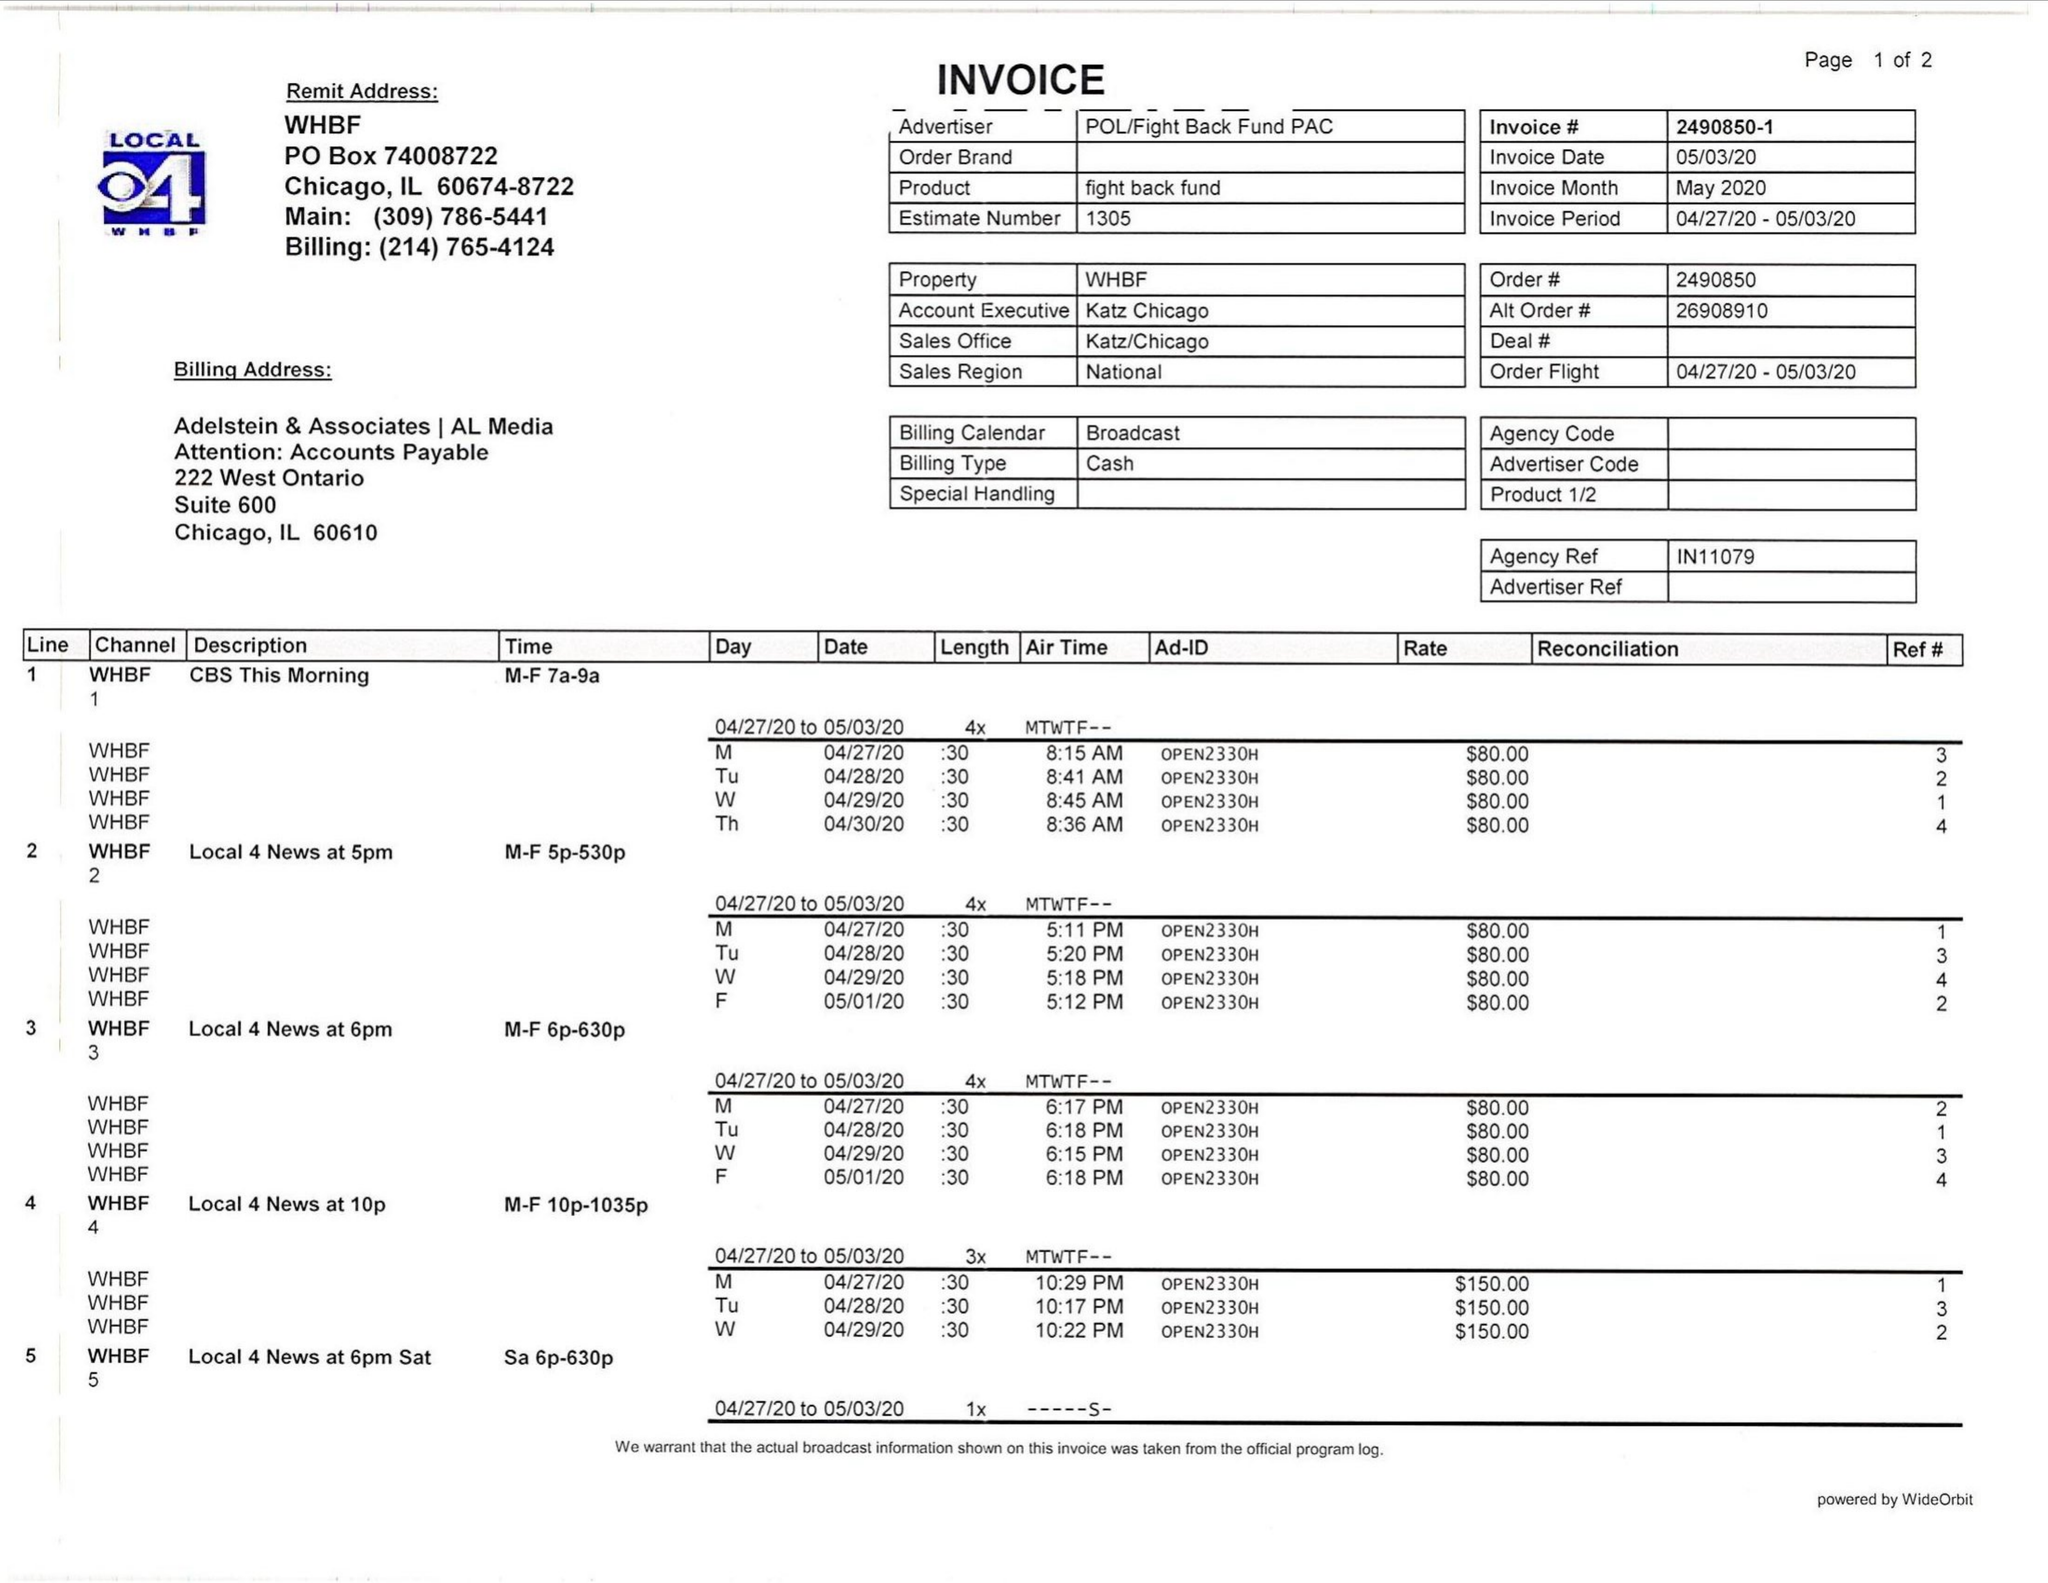What is the value for the gross_amount?
Answer the question using a single word or phrase. 1780.00 